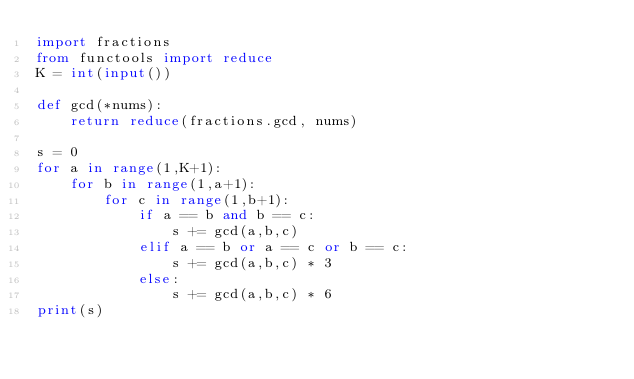Convert code to text. <code><loc_0><loc_0><loc_500><loc_500><_Python_>import fractions
from functools import reduce
K = int(input())

def gcd(*nums):
    return reduce(fractions.gcd, nums)

s = 0
for a in range(1,K+1):
    for b in range(1,a+1):
        for c in range(1,b+1):
            if a == b and b == c:
                s += gcd(a,b,c)
            elif a == b or a == c or b == c:
                s += gcd(a,b,c) * 3
            else:
                s += gcd(a,b,c) * 6
print(s)
</code> 